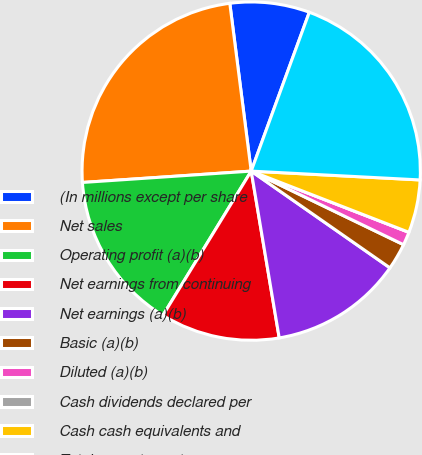Convert chart to OTSL. <chart><loc_0><loc_0><loc_500><loc_500><pie_chart><fcel>(In millions except per share<fcel>Net sales<fcel>Operating profit (a)(b)<fcel>Net earnings from continuing<fcel>Net earnings (a)(b)<fcel>Basic (a)(b)<fcel>Diluted (a)(b)<fcel>Cash dividends declared per<fcel>Cash cash equivalents and<fcel>Total current assets<nl><fcel>7.6%<fcel>24.05%<fcel>15.19%<fcel>11.39%<fcel>12.66%<fcel>2.53%<fcel>1.27%<fcel>0.0%<fcel>5.06%<fcel>20.25%<nl></chart> 